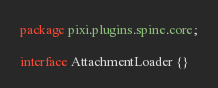Convert code to text. <code><loc_0><loc_0><loc_500><loc_500><_Haxe_>package pixi.plugins.spine.core;

interface AttachmentLoader {}
</code> 